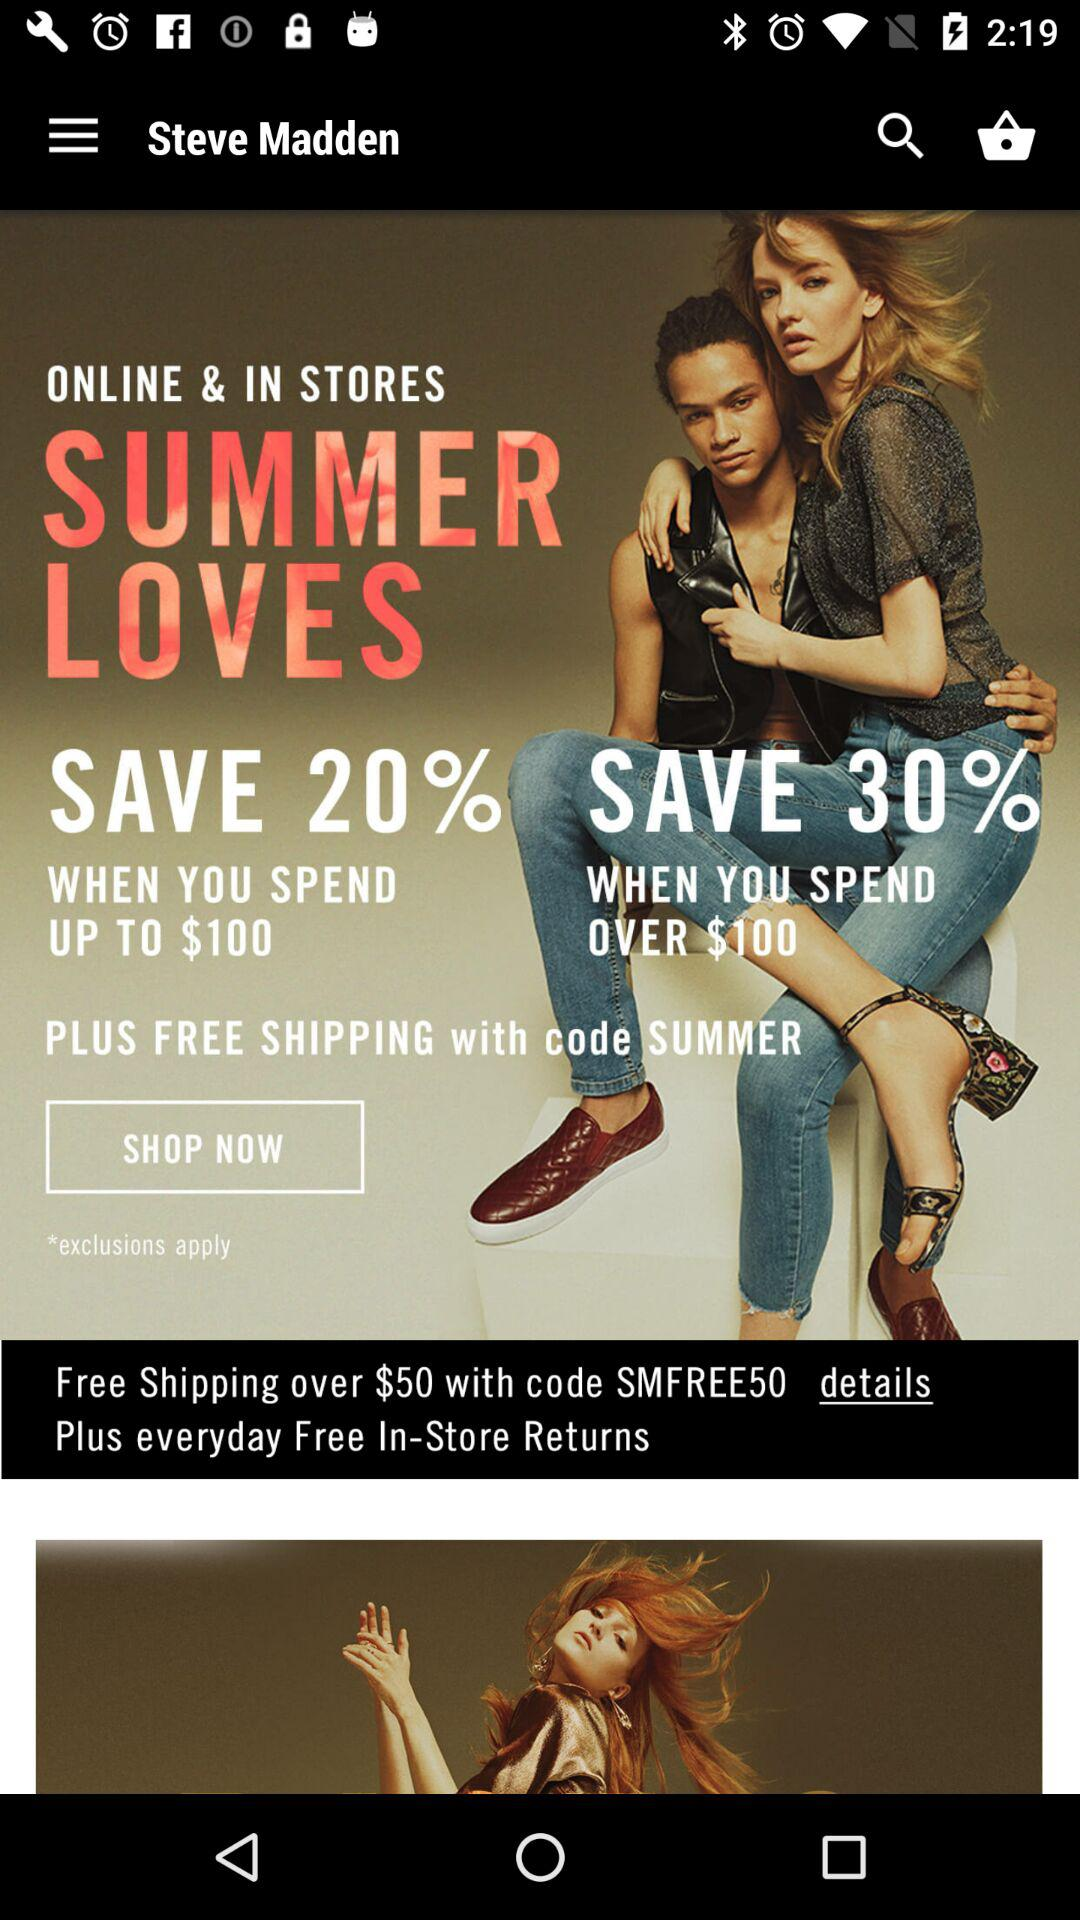How many more dollars do I need to spend to get 30% off my order?
Answer the question using a single word or phrase. $100 